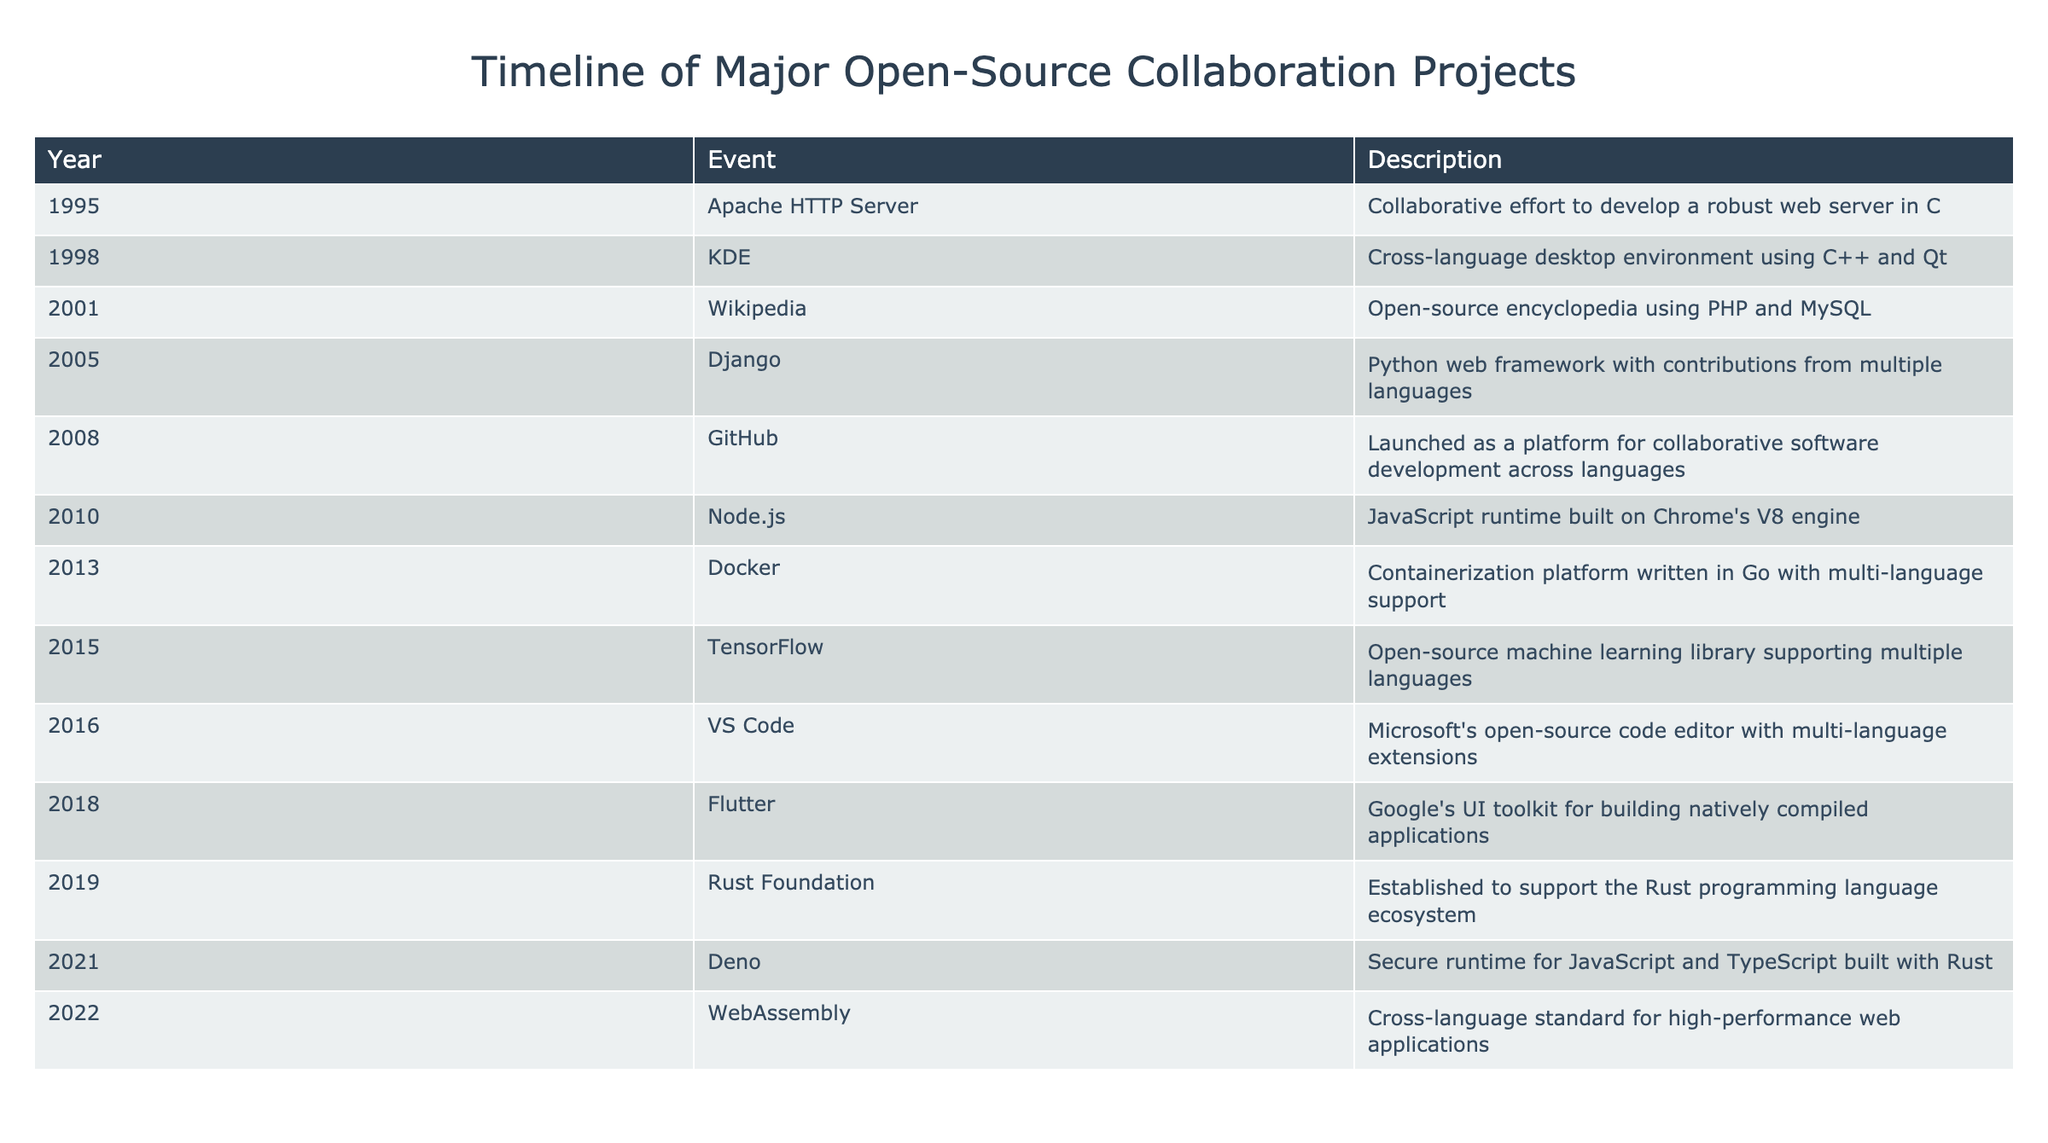What year was the Django project launched? The table lists the launch years for various projects, and Django is listed under the year 2005.
Answer: 2005 Which programming language was used to develop the Apache HTTP Server? According to the description in the table, the Apache HTTP Server was developed using the C programming language.
Answer: C Is the Rust Foundation established before or after Docker? The table shows that the Rust Foundation was established in 2019 and Docker was launched in 2013. Since 2019 is after 2013, the Rust Foundation was established after Docker.
Answer: After What is the average year of the first appearance of projects related to web technologies (Wikipedia, Django, Node.js, and Docker)? The years for these projects are 2001 (Wikipedia), 2005 (Django), 2010 (Node.js), and 2013 (Docker). Summing these gives 2001 + 2005 + 2010 + 2013 = 8029. There are 4 projects, so the average is 8029 / 4 = 2007.25, which can be rounded to 2007.
Answer: 2007 Were more programming projects launched in the 2010s than in the 2000s? The table shows there are 5 projects from the 2010s (Node.js, Docker, TensorFlow, VS Code, Flutter) and 4 projects from the 2000s (Apache HTTP Server, KDE, Wikipedia, Django). Since 5 is greater than 4, there were more projects in the 2010s.
Answer: Yes Which project listed was specifically aimed at cross-language high-performance web applications? The table indicates that WebAssembly, established in 2022, is a cross-language standard aimed at high-performance web applications.
Answer: WebAssembly How many years apart were the launches of the Django project and the Node.js project? The Django project launched in 2005 and Node.js launched in 2010. The difference between these years is 2010 - 2005 = 5 years.
Answer: 5 years What was the primary programming language of the containerization platform Docker? Docker, as stated in the table, was written in Go.
Answer: Go List the projects that were introduced after 2015. The projects after 2015 listed in the table are VS Code (2016), Deno (2021), and WebAssembly (2022). This means there are three projects introduced after 2015.
Answer: 3 projects (VS Code, Deno, WebAssembly) 